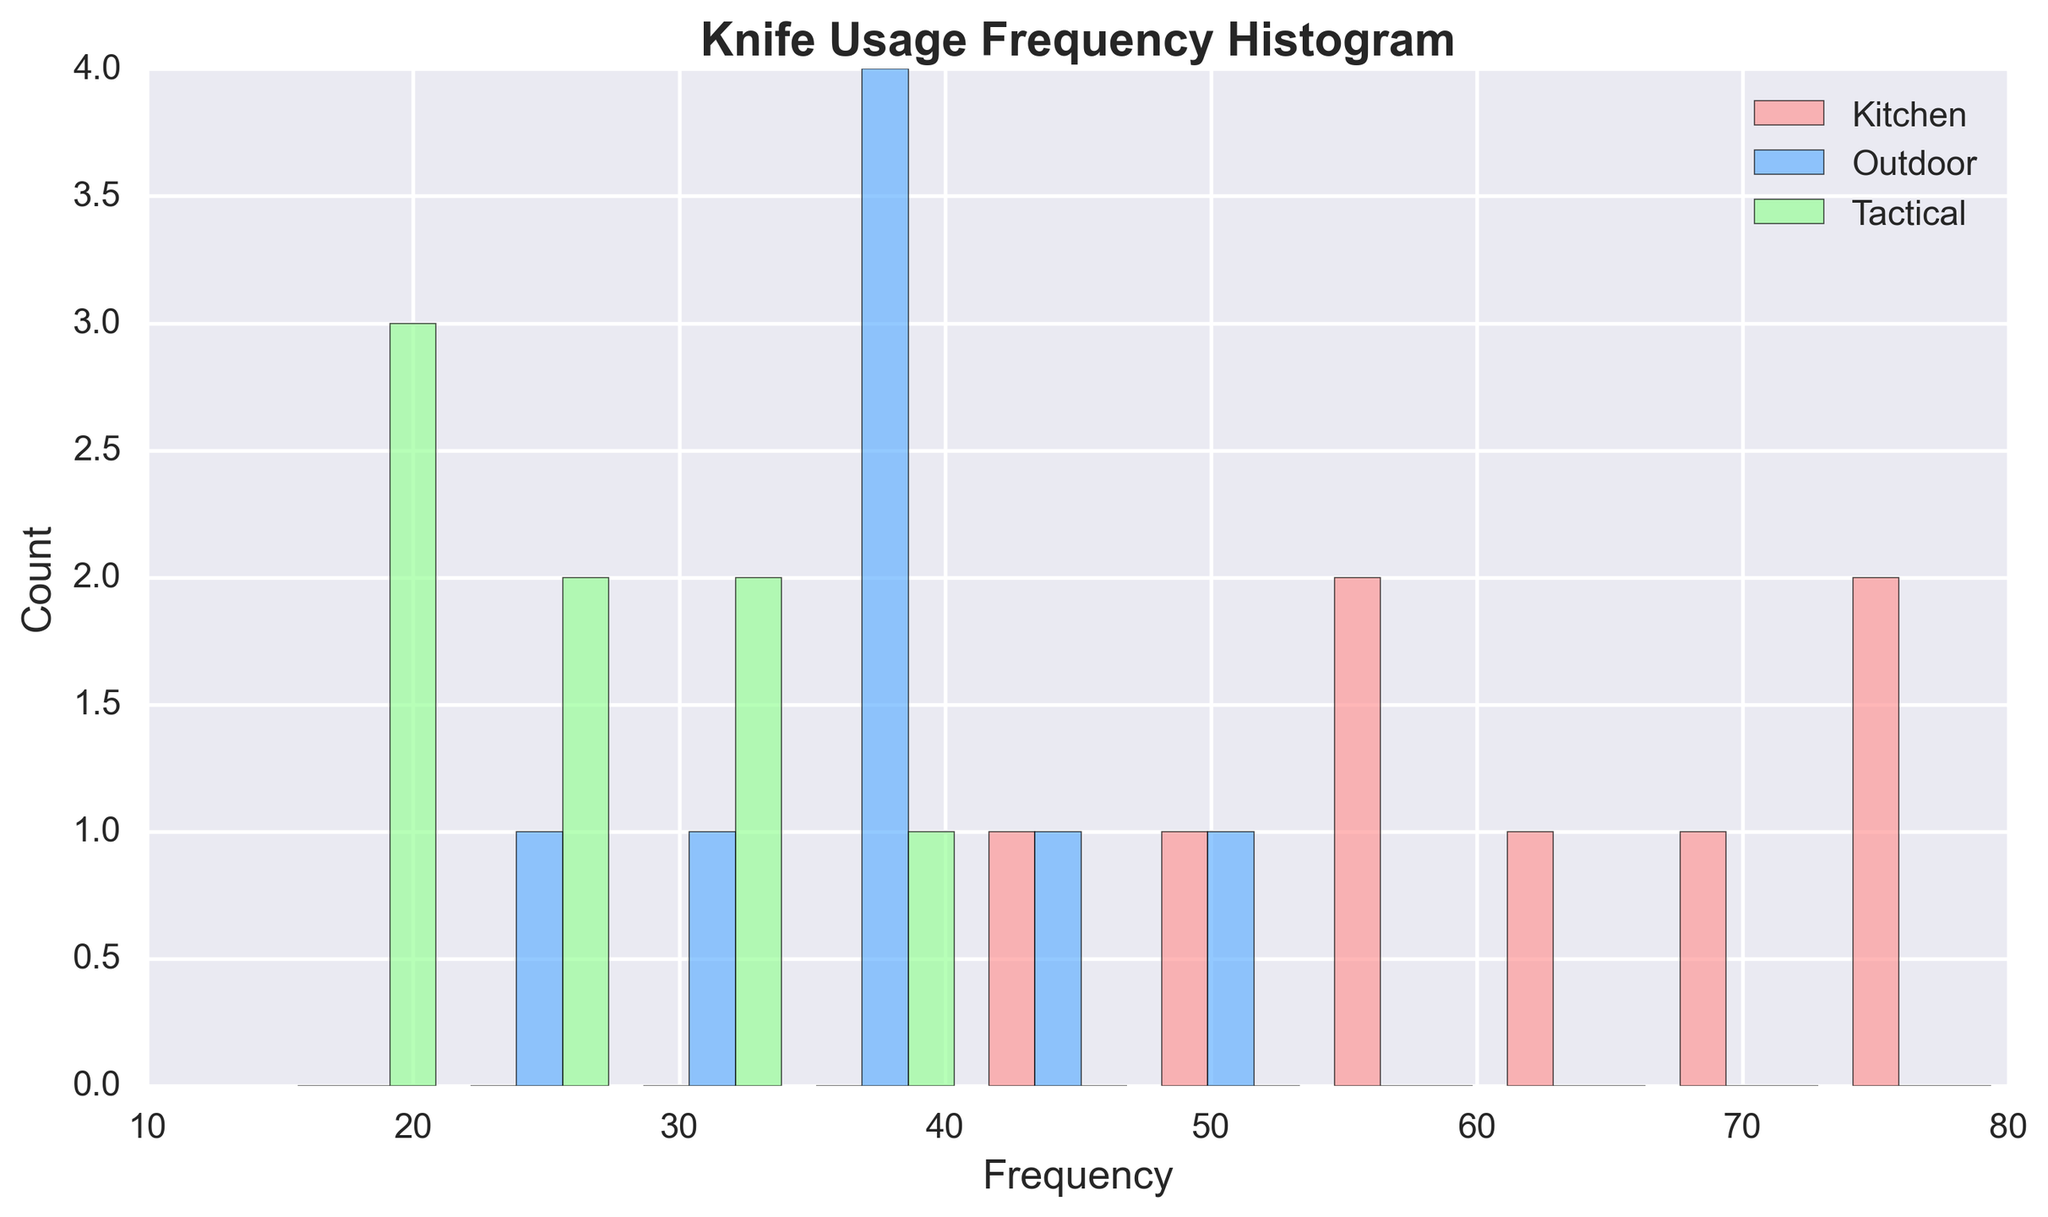Which knife usage type has the highest frequency of use? The histogram's tallest bar represents the most frequent usage type. By visually inspecting, the "Kitchen" category has the highest bars indicating it's the most frequently used type.
Answer: Kitchen How does the usage frequency for the "Outdoor" knives compare to the "Tactical" knives? Looking at the heights of the bars, the "Outdoor" frequency bars are generally taller than the "Tactical" frequency bars, indicating that "Outdoor" knives are used more frequently than "Tactical" knives.
Answer: Outdoor > Tactical What is the total frequency of the "Kitchen" knife usage type? Summing up the frequency values for the "Kitchen" category: 45 + 50 + 55 + 60 + 65 + 70 + 75 + 80 = 500. Thus, the total frequency is 500.
Answer: 500 Is there any category whose frequency exceeds 70 more than once? Checking the bars closely, only the "Kitchen" category has frequency values that exceed 70 multiple times (twice: at 75 and 80).
Answer: Yes What is the highest recorded frequency in the histogram, and which category does it belong to? By looking at the histogram, the highest bar represents a frequency of 80, which belongs to the "Kitchen" category.
Answer: 80, Kitchen What is the average frequency of the "Tactical" knives? Summing up the frequency values for "Tactical" knives (25 + 20 + 30 + 15 + 35 + 25 + 20 + 30) and dividing by the number of entries (8), we get (200 / 8 = 25).
Answer: 25 If we combine the total frequencies of "Outdoor" and "Tactical" knives, how does it compare to "Kitchen"? Summing the frequencies for "Outdoor" (30 + 40 + 35 + 45 + 25 + 40 + 35 + 50 = 300) and "Tactical" (25 + 20 + 30 + 15 + 35 + 25 + 20 + 30 = 200), we get 300 + 200 = 500. The total frequency for "Kitchen" is also 500, so they are equal.
Answer: Equal Which category has the lowest variability in frequency? By comparing the range of frequencies for each category: "Kitchen" ranges from 45 to 80 (35), "Outdoor" ranges from 25 to 50 (25), and "Tactical" ranges from 15 to 35 (20). Thus, "Tactical" has the lowest variability.
Answer: Tactical What can you infer about the general usage trends of the knives based on the histogram? The "Kitchen" knives are used most frequently and consistently have higher frequencies, followed by "Outdoor" knives, suggesting they are used moderately often. "Tactical" knives are the least used, with the lowest frequency and more consistently lower values. This indicates a preference for "Kitchen" over "Outdoor" and "Tactical" knives.
Answer: Kitchen > Outdoor > Tactical 